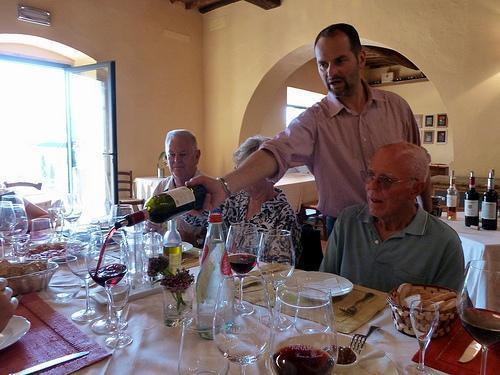How many people are sitting?
Give a very brief answer. 4. How many people are in this picture?
Give a very brief answer. 5. 